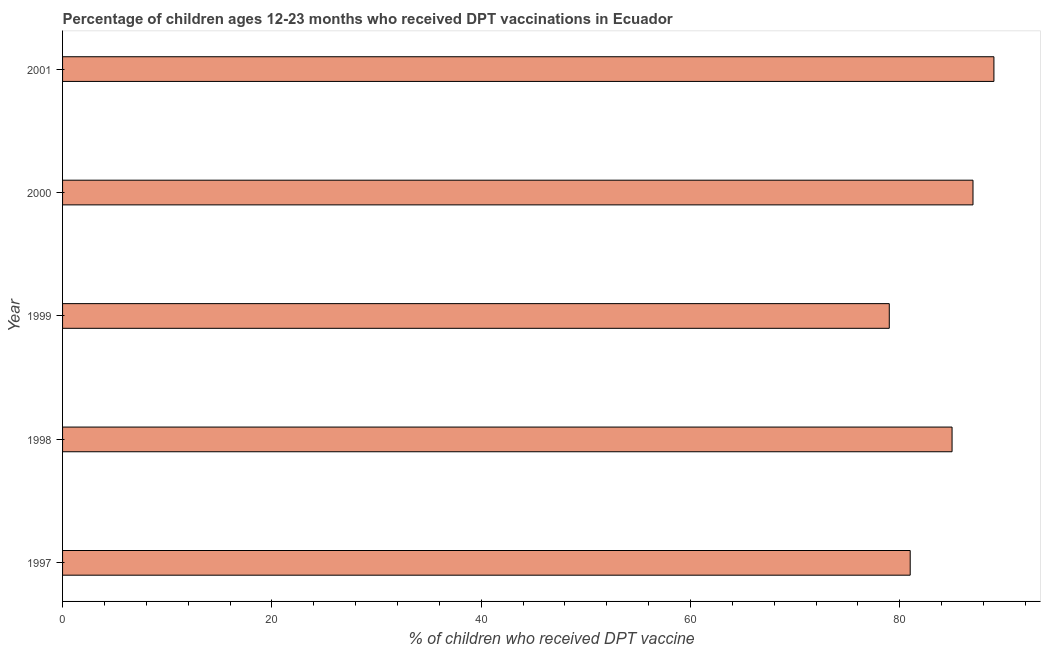Does the graph contain any zero values?
Keep it short and to the point. No. Does the graph contain grids?
Ensure brevity in your answer.  No. What is the title of the graph?
Provide a succinct answer. Percentage of children ages 12-23 months who received DPT vaccinations in Ecuador. What is the label or title of the X-axis?
Provide a short and direct response. % of children who received DPT vaccine. What is the percentage of children who received dpt vaccine in 2001?
Provide a short and direct response. 89. Across all years, what is the maximum percentage of children who received dpt vaccine?
Your answer should be very brief. 89. Across all years, what is the minimum percentage of children who received dpt vaccine?
Your answer should be compact. 79. In which year was the percentage of children who received dpt vaccine maximum?
Offer a very short reply. 2001. In which year was the percentage of children who received dpt vaccine minimum?
Ensure brevity in your answer.  1999. What is the sum of the percentage of children who received dpt vaccine?
Your answer should be compact. 421. What is the difference between the percentage of children who received dpt vaccine in 1997 and 1998?
Your answer should be compact. -4. What is the average percentage of children who received dpt vaccine per year?
Provide a succinct answer. 84. What is the median percentage of children who received dpt vaccine?
Provide a succinct answer. 85. Do a majority of the years between 2001 and 1997 (inclusive) have percentage of children who received dpt vaccine greater than 48 %?
Your response must be concise. Yes. What is the ratio of the percentage of children who received dpt vaccine in 1998 to that in 2000?
Your answer should be compact. 0.98. What is the difference between the highest and the lowest percentage of children who received dpt vaccine?
Ensure brevity in your answer.  10. In how many years, is the percentage of children who received dpt vaccine greater than the average percentage of children who received dpt vaccine taken over all years?
Provide a short and direct response. 3. Are all the bars in the graph horizontal?
Ensure brevity in your answer.  Yes. How many years are there in the graph?
Your answer should be very brief. 5. What is the difference between two consecutive major ticks on the X-axis?
Keep it short and to the point. 20. Are the values on the major ticks of X-axis written in scientific E-notation?
Keep it short and to the point. No. What is the % of children who received DPT vaccine of 1997?
Offer a very short reply. 81. What is the % of children who received DPT vaccine in 1998?
Give a very brief answer. 85. What is the % of children who received DPT vaccine in 1999?
Provide a short and direct response. 79. What is the % of children who received DPT vaccine of 2000?
Provide a short and direct response. 87. What is the % of children who received DPT vaccine of 2001?
Make the answer very short. 89. What is the difference between the % of children who received DPT vaccine in 1997 and 1998?
Give a very brief answer. -4. What is the difference between the % of children who received DPT vaccine in 1997 and 2001?
Offer a terse response. -8. What is the difference between the % of children who received DPT vaccine in 1998 and 2000?
Your answer should be compact. -2. What is the difference between the % of children who received DPT vaccine in 2000 and 2001?
Offer a very short reply. -2. What is the ratio of the % of children who received DPT vaccine in 1997 to that in 1998?
Ensure brevity in your answer.  0.95. What is the ratio of the % of children who received DPT vaccine in 1997 to that in 1999?
Give a very brief answer. 1.02. What is the ratio of the % of children who received DPT vaccine in 1997 to that in 2000?
Make the answer very short. 0.93. What is the ratio of the % of children who received DPT vaccine in 1997 to that in 2001?
Keep it short and to the point. 0.91. What is the ratio of the % of children who received DPT vaccine in 1998 to that in 1999?
Your answer should be compact. 1.08. What is the ratio of the % of children who received DPT vaccine in 1998 to that in 2001?
Provide a short and direct response. 0.95. What is the ratio of the % of children who received DPT vaccine in 1999 to that in 2000?
Ensure brevity in your answer.  0.91. What is the ratio of the % of children who received DPT vaccine in 1999 to that in 2001?
Offer a terse response. 0.89. 